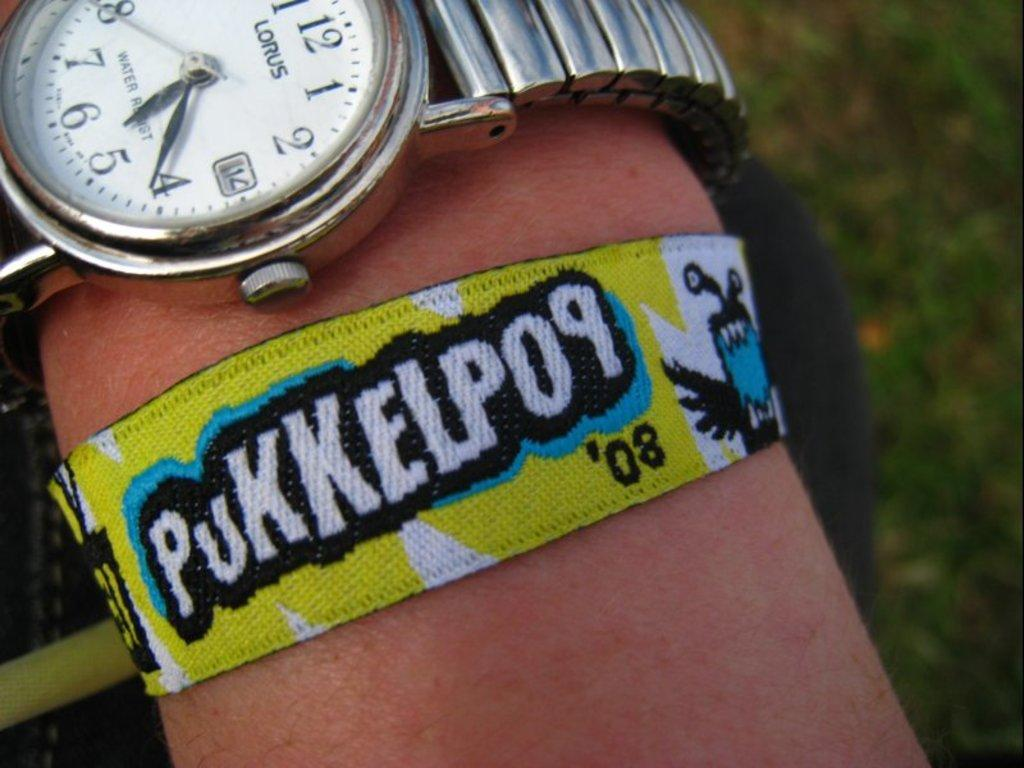Provide a one-sentence caption for the provided image. A person displaying a wristband they are wearing at 5:21. 